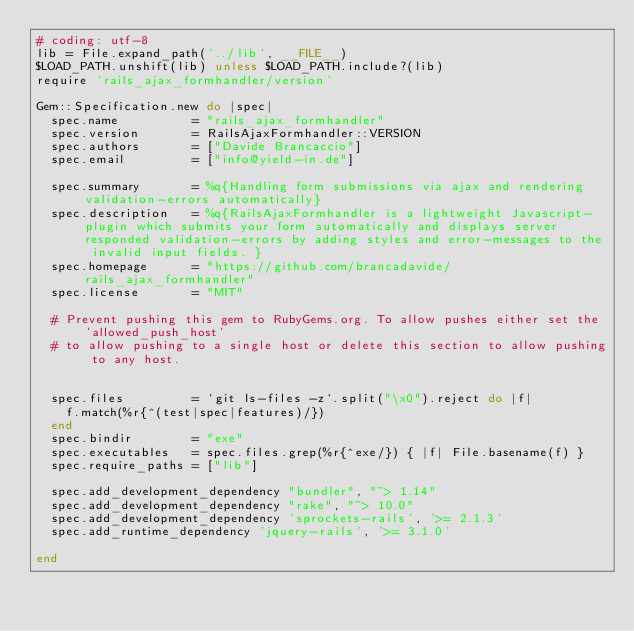Convert code to text. <code><loc_0><loc_0><loc_500><loc_500><_Ruby_># coding: utf-8
lib = File.expand_path('../lib', __FILE__)
$LOAD_PATH.unshift(lib) unless $LOAD_PATH.include?(lib)
require 'rails_ajax_formhandler/version'

Gem::Specification.new do |spec|
  spec.name          = "rails_ajax_formhandler"
  spec.version       = RailsAjaxFormhandler::VERSION
  spec.authors       = ["Davide Brancaccio"]
  spec.email         = ["info@yield-in.de"]

  spec.summary       = %q{Handling form submissions via ajax and rendering validation-errors automatically}
  spec.description   = %q{RailsAjaxFormhandler is a lightweight Javascript-plugin which submits your form automatically and displays server responded validation-errors by adding styles and error-messages to the invalid input fields. }
  spec.homepage      = "https://github.com/brancadavide/rails_ajax_formhandler"
  spec.license       = "MIT"

  # Prevent pushing this gem to RubyGems.org. To allow pushes either set the 'allowed_push_host'
  # to allow pushing to a single host or delete this section to allow pushing to any host.


  spec.files         = `git ls-files -z`.split("\x0").reject do |f|
    f.match(%r{^(test|spec|features)/})
  end
  spec.bindir        = "exe"
  spec.executables   = spec.files.grep(%r{^exe/}) { |f| File.basename(f) }
  spec.require_paths = ["lib"]

  spec.add_development_dependency "bundler", "~> 1.14"
  spec.add_development_dependency "rake", "~> 10.0"
  spec.add_development_dependency 'sprockets-rails', '>= 2.1.3'
  spec.add_runtime_dependency 'jquery-rails', '>= 3.1.0'

end
</code> 